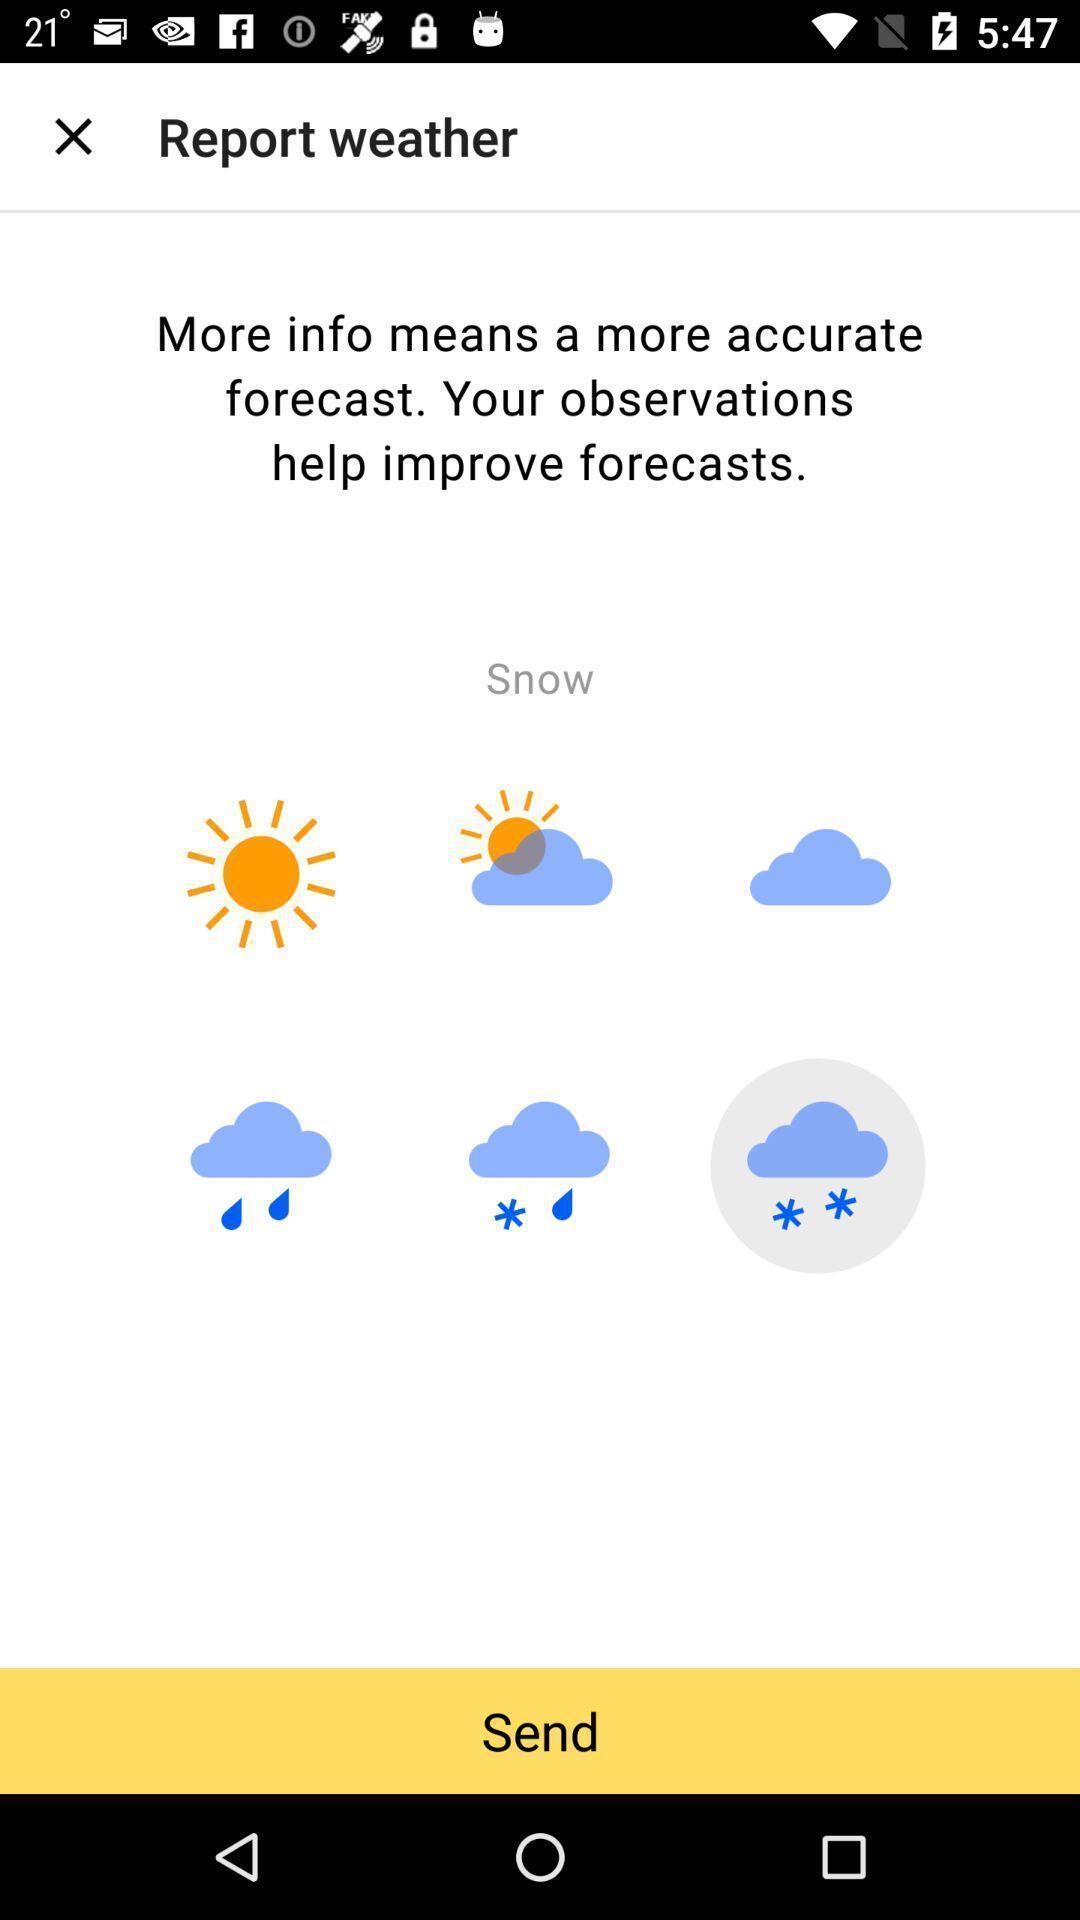Explain what's happening in this screen capture. Page shows about reporting weather conditions. 